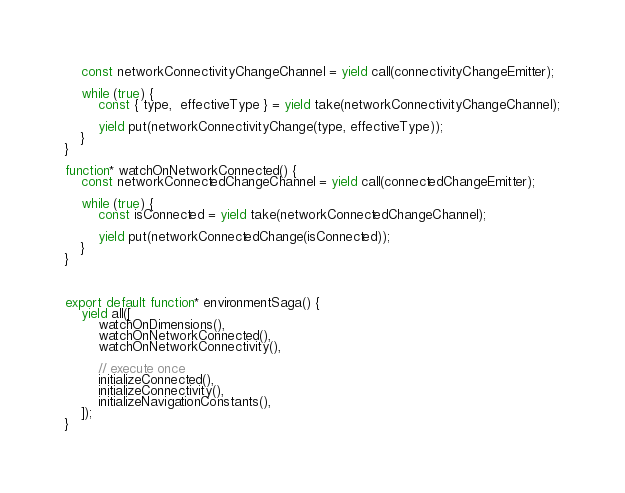Convert code to text. <code><loc_0><loc_0><loc_500><loc_500><_JavaScript_>    const networkConnectivityChangeChannel = yield call(connectivityChangeEmitter);

    while (true) {
        const { type,  effectiveType } = yield take(networkConnectivityChangeChannel);

        yield put(networkConnectivityChange(type, effectiveType));
    }
}

function* watchOnNetworkConnected() {
    const networkConnectedChangeChannel = yield call(connectedChangeEmitter);

    while (true) {
        const isConnected = yield take(networkConnectedChangeChannel);

        yield put(networkConnectedChange(isConnected));
    }
}



export default function* environmentSaga() {
    yield all([
        watchOnDimensions(),
        watchOnNetworkConnected(),
        watchOnNetworkConnectivity(),

        // execute once
        initializeConnected(),
        initializeConnectivity(),
        initializeNavigationConstants(),
    ]);
}</code> 